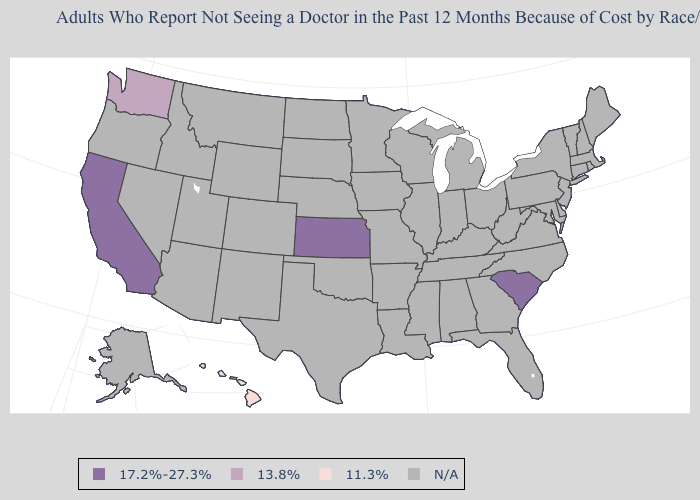Which states have the highest value in the USA?
Give a very brief answer. California, Kansas, South Carolina. Name the states that have a value in the range 11.3%?
Write a very short answer. Hawaii. What is the value of Connecticut?
Concise answer only. N/A. What is the value of Louisiana?
Write a very short answer. N/A. Name the states that have a value in the range 13.8%?
Give a very brief answer. Washington. What is the value of Hawaii?
Quick response, please. 11.3%. Name the states that have a value in the range 11.3%?
Quick response, please. Hawaii. Name the states that have a value in the range 13.8%?
Quick response, please. Washington. What is the value of Alabama?
Write a very short answer. N/A. Does the map have missing data?
Write a very short answer. Yes. What is the value of Nevada?
Concise answer only. N/A. Among the states that border Nebraska , which have the lowest value?
Concise answer only. Kansas. 